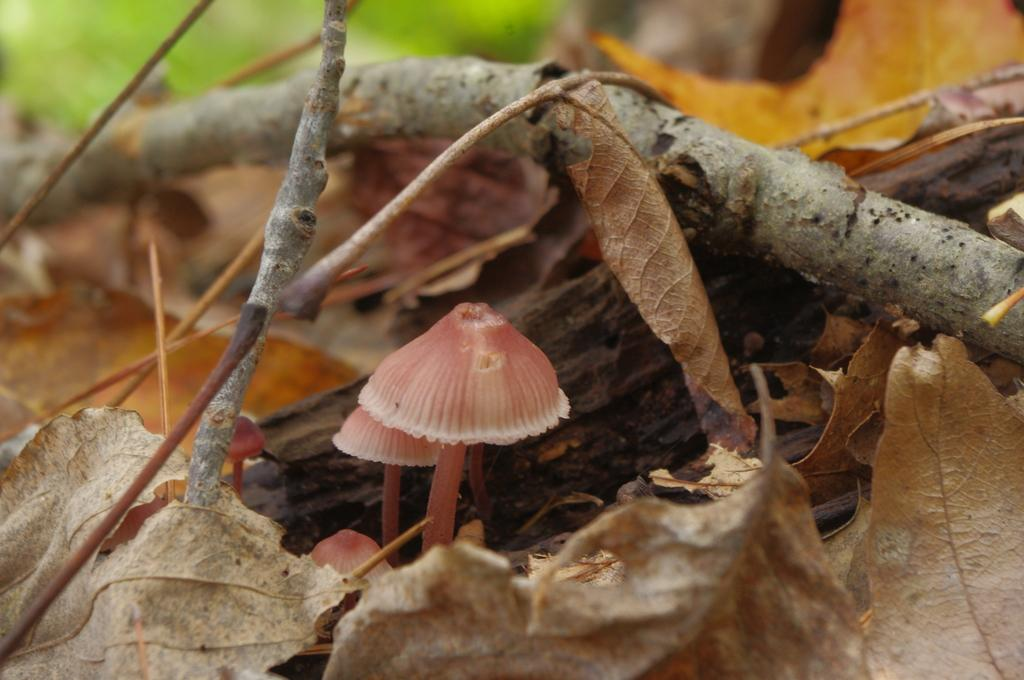What type of fungi can be seen in the image? There are mushrooms in the image. What type of natural material is present in the image? There are wooden branches in the image. What type of plant material can be seen in the image? Dry leaves are present in the image. What is the name of the brother who lives in the image? There is no person or brother present in the image, so this question cannot be answered. 